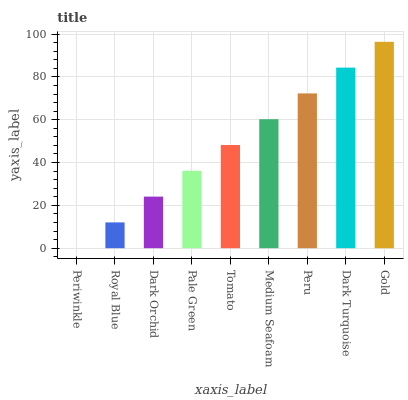Is Periwinkle the minimum?
Answer yes or no. Yes. Is Gold the maximum?
Answer yes or no. Yes. Is Royal Blue the minimum?
Answer yes or no. No. Is Royal Blue the maximum?
Answer yes or no. No. Is Royal Blue greater than Periwinkle?
Answer yes or no. Yes. Is Periwinkle less than Royal Blue?
Answer yes or no. Yes. Is Periwinkle greater than Royal Blue?
Answer yes or no. No. Is Royal Blue less than Periwinkle?
Answer yes or no. No. Is Tomato the high median?
Answer yes or no. Yes. Is Tomato the low median?
Answer yes or no. Yes. Is Dark Turquoise the high median?
Answer yes or no. No. Is Periwinkle the low median?
Answer yes or no. No. 